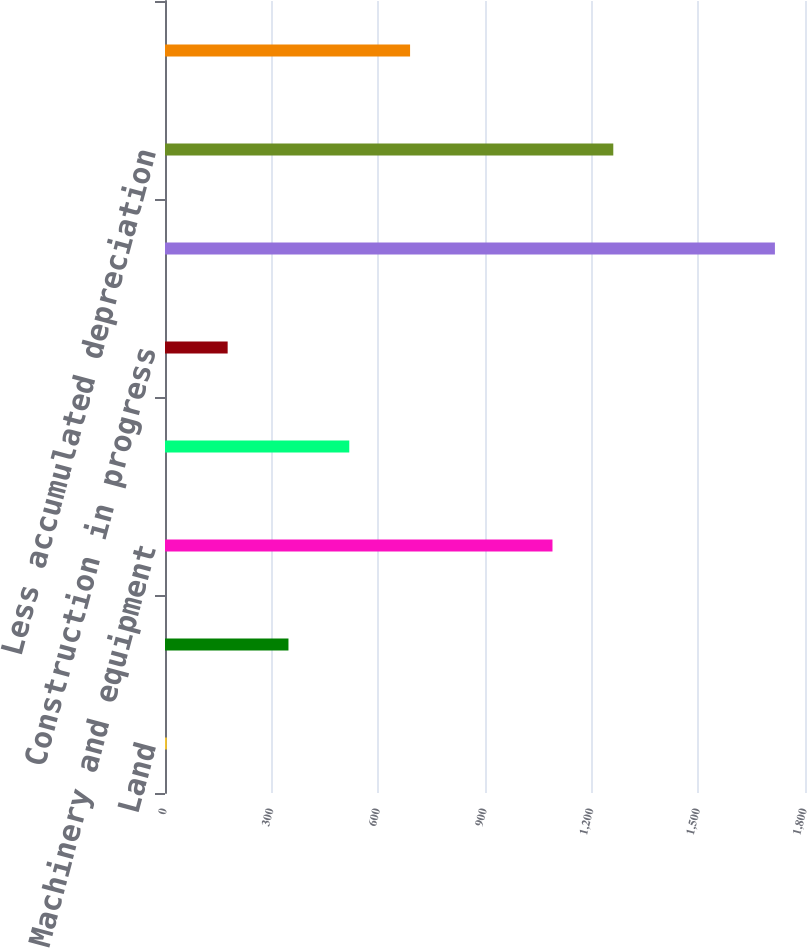Convert chart. <chart><loc_0><loc_0><loc_500><loc_500><bar_chart><fcel>Land<fcel>Buildings and improvements<fcel>Machinery and equipment<fcel>Internal use software<fcel>Construction in progress<fcel>Total<fcel>Less accumulated depreciation<fcel>Property net<nl><fcel>5.2<fcel>347.24<fcel>1089.8<fcel>518.26<fcel>176.22<fcel>1715.4<fcel>1260.82<fcel>689.28<nl></chart> 